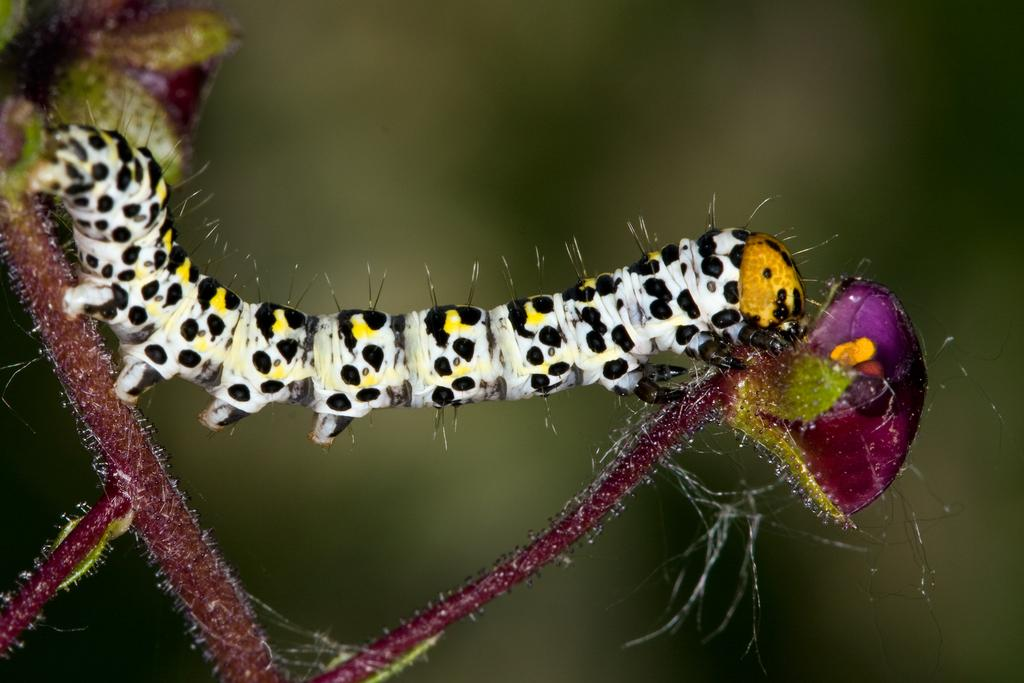What is the main subject of the image? The main subject of the image is a caterpillar. Can you describe the appearance of the caterpillar? The caterpillar is off-white, yellow, and black in color. Where is the caterpillar located in the image? The caterpillar is on a plant. How would you describe the background of the image? The background of the image is blurred. What type of glue is being used to hold the caterpillar's foot in the image? There is no glue or foot present in the image; it features a caterpillar on a plant with a blurred background. Can you tell me how many tombstones are visible in the cemetery in the image? There is no cemetery present in the image; it features a caterpillar on a plant with a blurred background. 